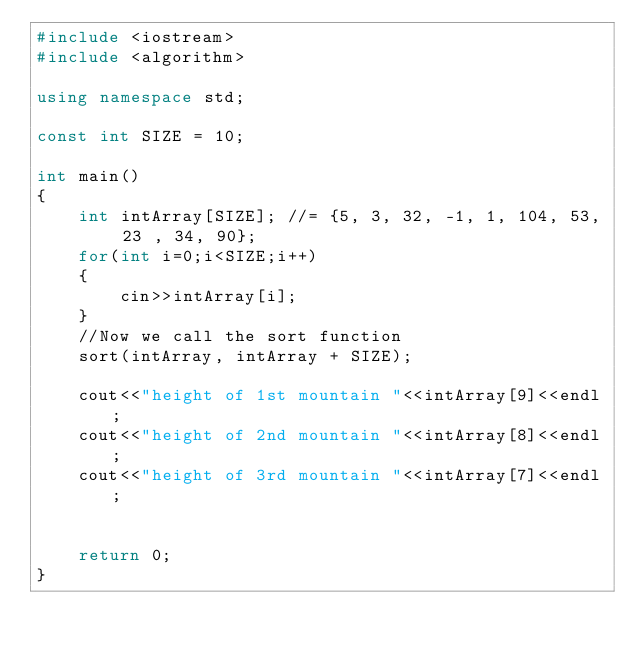Convert code to text. <code><loc_0><loc_0><loc_500><loc_500><_C++_>#include <iostream>
#include <algorithm>

using namespace std;

const int SIZE = 10;

int main()
{
    int intArray[SIZE]; //= {5, 3, 32, -1, 1, 104, 53, 23 , 34, 90};
    for(int i=0;i<SIZE;i++)
    {
        cin>>intArray[i];
    }
    //Now we call the sort function
    sort(intArray, intArray + SIZE);

    cout<<"height of 1st mountain "<<intArray[9]<<endl;
    cout<<"height of 2nd mountain "<<intArray[8]<<endl;
    cout<<"height of 3rd mountain "<<intArray[7]<<endl;


    return 0;
}</code> 